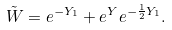Convert formula to latex. <formula><loc_0><loc_0><loc_500><loc_500>\tilde { W } = e ^ { - Y _ { 1 } } + e ^ { Y } e ^ { - \frac { 1 } { 2 } Y _ { 1 } } .</formula> 